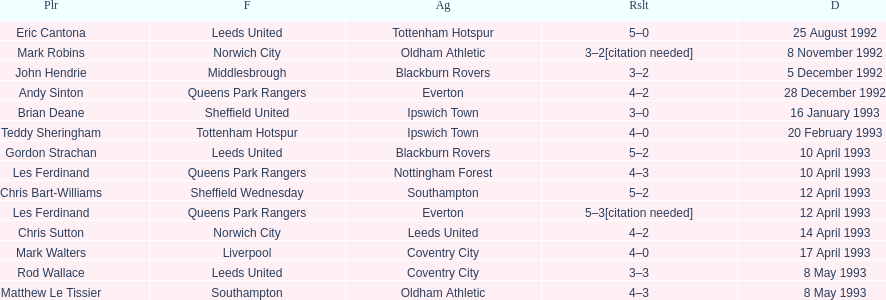Which team did liverpool play against? Coventry City. 